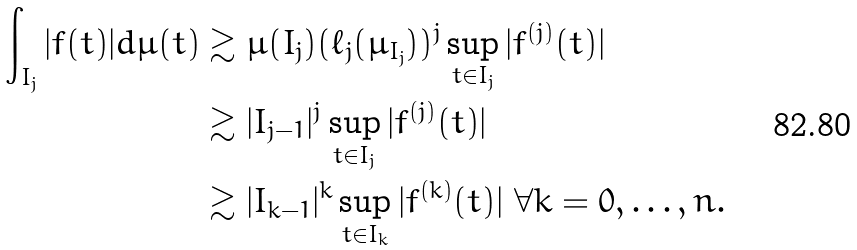Convert formula to latex. <formula><loc_0><loc_0><loc_500><loc_500>\int _ { I _ { j } } | f ( t ) | d \mu ( t ) & \gtrsim \mu ( I _ { j } ) ( \ell _ { j } ( \mu _ { I _ { j } } ) ) ^ { j } \sup _ { t \in I _ { j } } | f ^ { ( j ) } ( t ) | \\ & \gtrsim | I _ { j - 1 } | ^ { j } \sup _ { t \in I _ { j } } | f ^ { ( j ) } ( t ) | \\ & \gtrsim | I _ { k - 1 } | ^ { k } \sup _ { t \in I _ { k } } | f ^ { ( k ) } ( t ) | \ \forall k = 0 , \dots , n .</formula> 